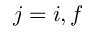<formula> <loc_0><loc_0><loc_500><loc_500>j = i , f</formula> 